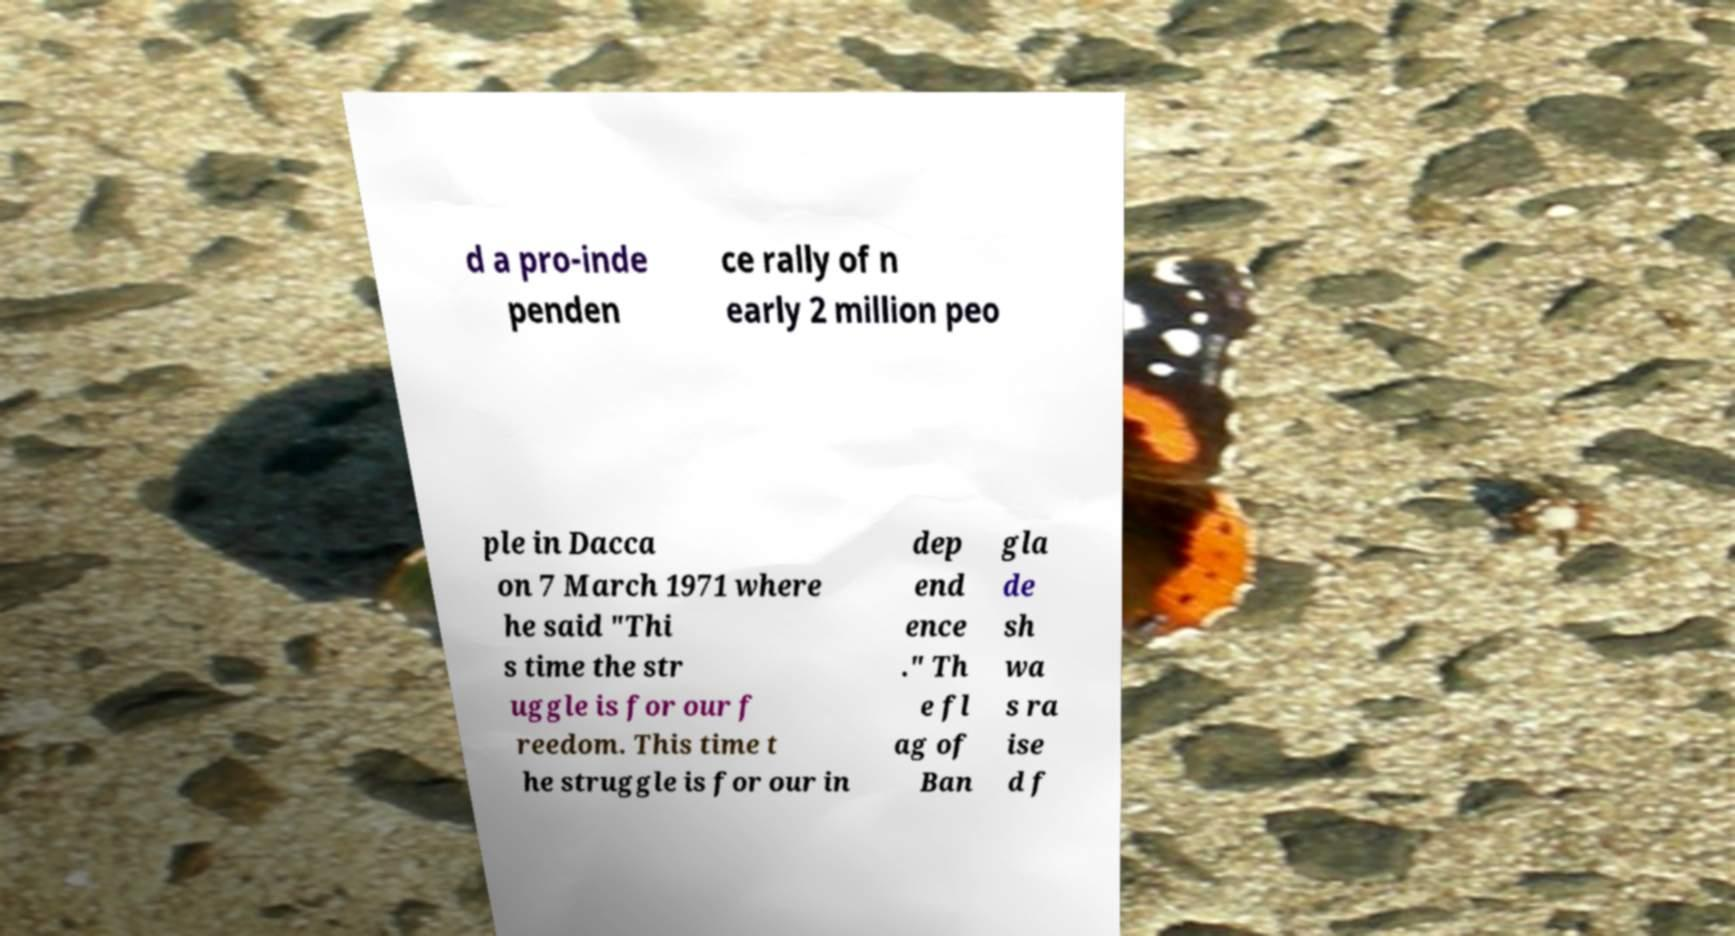Can you accurately transcribe the text from the provided image for me? d a pro-inde penden ce rally of n early 2 million peo ple in Dacca on 7 March 1971 where he said "Thi s time the str uggle is for our f reedom. This time t he struggle is for our in dep end ence ." Th e fl ag of Ban gla de sh wa s ra ise d f 